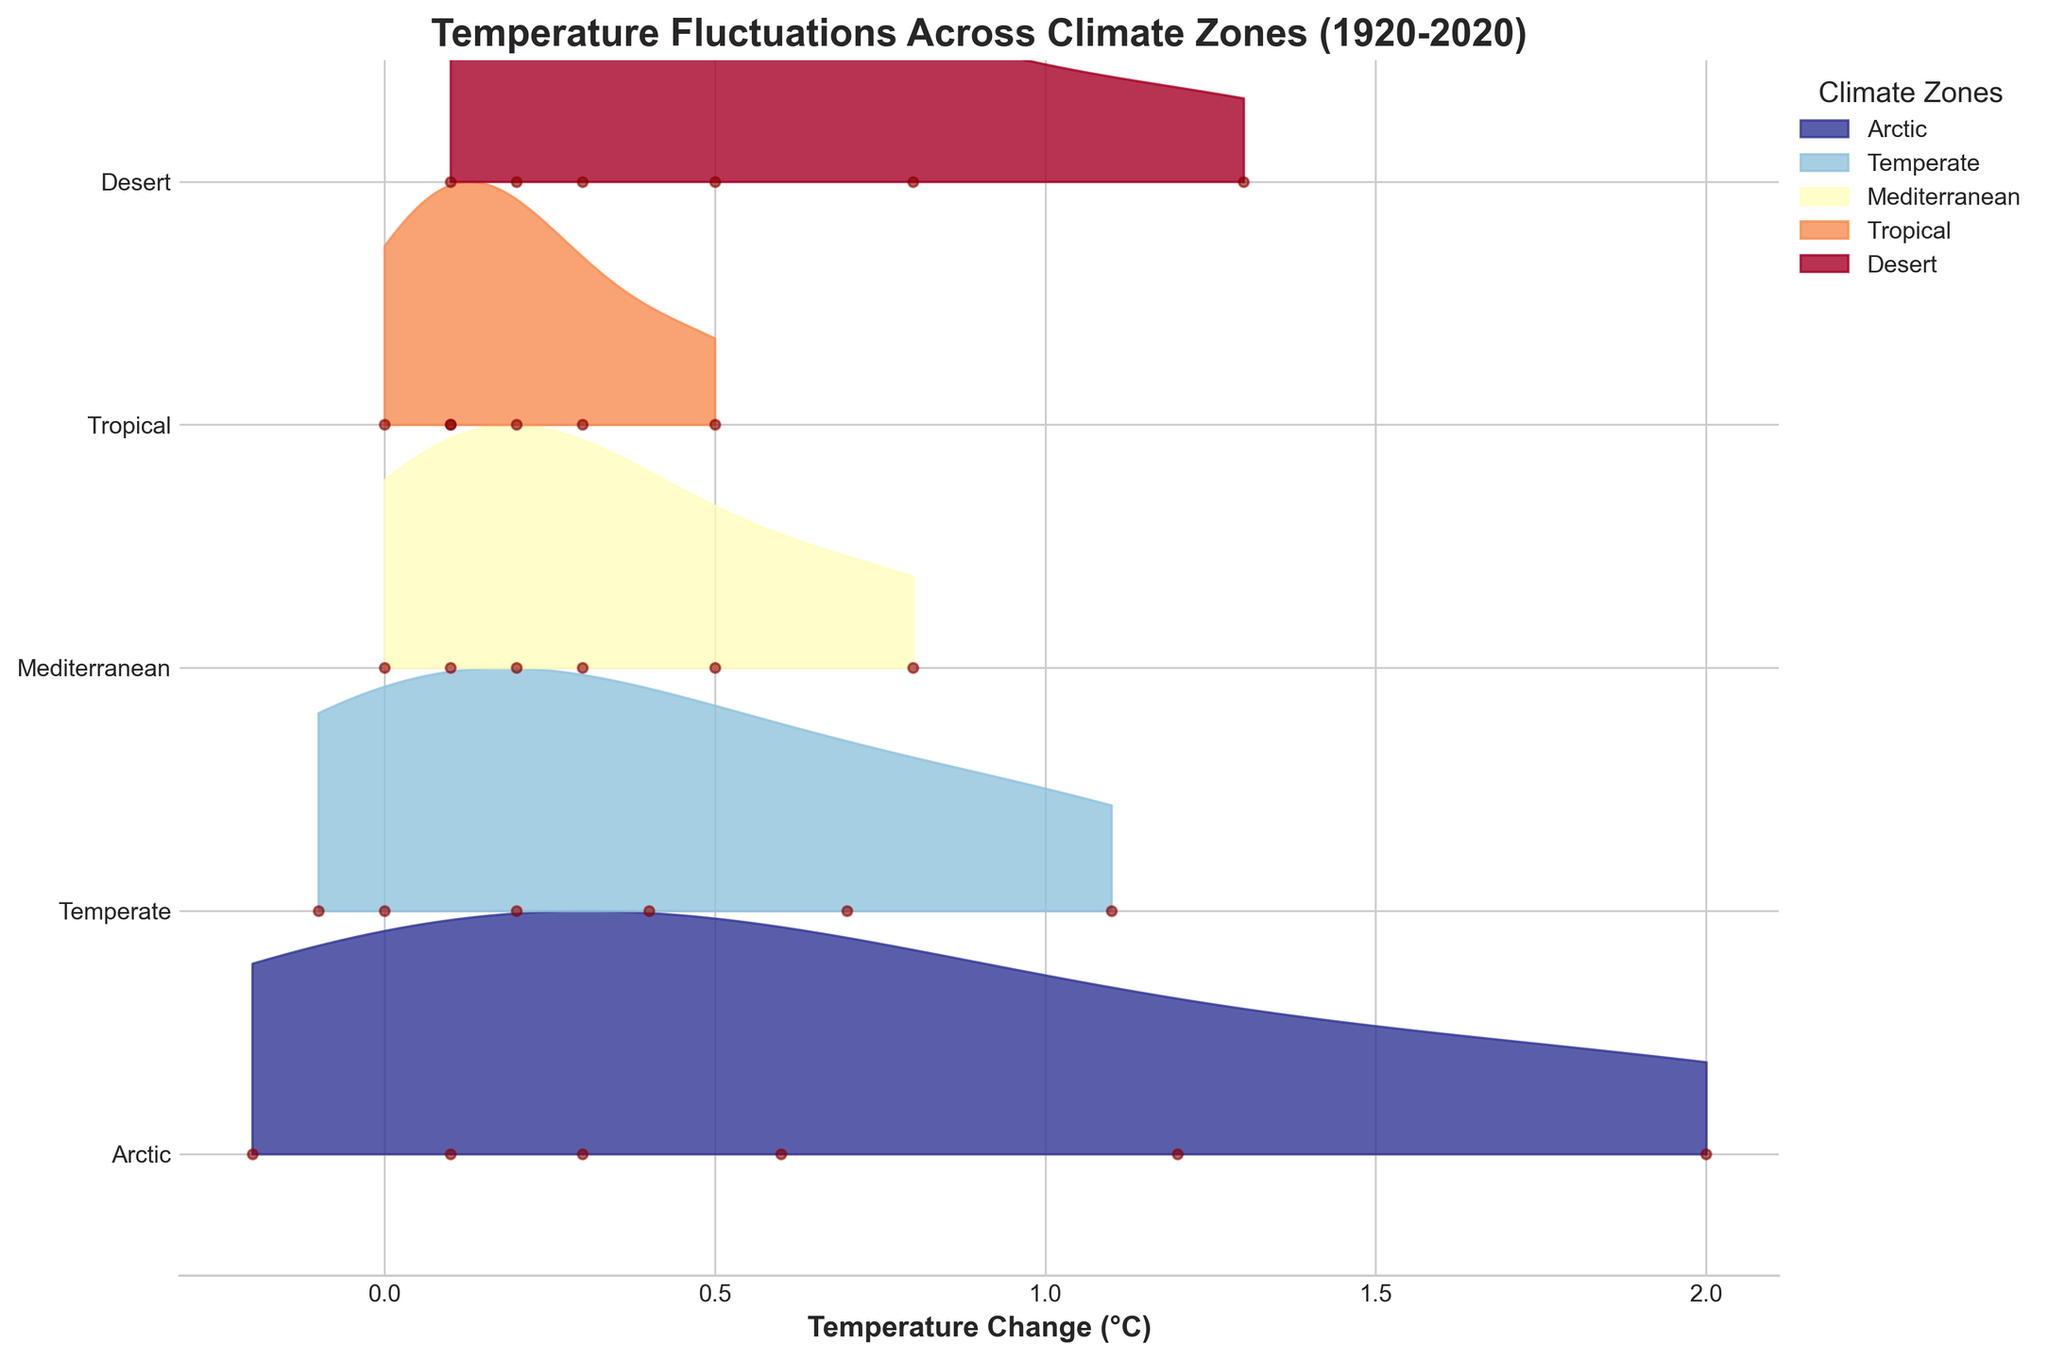What is the title of the figure? The title is the text located at the top of the figure. It gives an overview of what the plot represents. In this case, it is "Temperature Fluctuations Across Climate Zones (1920-2020)".
Answer: Temperature Fluctuations Across Climate Zones (1920-2020) Which climate zone has the highest temperature change in 2020? Identify the temperature changes for each climate zone in 2020. The Arctic has a temperature change of 2.0°C, which is the highest among all listed zones.
Answer: Arctic How many climate zones are represented in the plot? Each unique climate zone is represented by a line in the ridgeline plot. By counting the labels on the y-axis, we find there are five climate zones.
Answer: 5 Describe the trend in temperature change for the Arctic from 1920 to 2020. Observe the data points for the Arctic climate zone over the years. The temperature change increases monotonically from -0.2°C in 1920 to 2.0°C in 2020.
Answer: Increasing Which climate zone had the smallest temperature change in 1980? Look at the 1980 data points for all climate zones and compare their values. The Tropical climate zone has the smallest temperature change of 0.2°C in that year.
Answer: Tropical How do the temperature changes in the Temperate and Mediterranean climate zones compare in 2000? Compare the temperature changes for both zones in the year 2000. The Temperate zone has a temperature change of 0.7°C, while the Mediterranean zone has a change of 0.5°C. The Temperate zone’s change is higher.
Answer: Temperate zone is higher Between which two years did the Arctic climate zone experience the largest increase in temperature change? Calculate the differences in temperature change between consecutive years for the Arctic zone. The largest increase is from 2000 to 2020, where the change is from 1.2°C to 2.0°C, a difference of 0.8°C.
Answer: 2000 to 2020 What is a unique feature of the ridgeline plot used to display this data? A unique feature of a ridgeline plot is the overlapping density curves that show the distribution of values across categories. In this case, it helps to visualize temperature changes across multiple climate zones simultaneously.
Answer: Overlapping density curves How does the temperature change trend in the Desert climate zone compare to that in the Arctic climate zone from 1920 to 2020? Both the Arctic and Desert zones show an increasing trend. However, the Arctic’s increase is steeper, starting from -0.2°C to 2.0°C, whereas the Desert starts at 0.1°C to 1.3°C. The Arctic’s overall increase is larger.
Answer: Arctic has a steeper increase Which climate zone shows the least variation in temperature changes over the years? By observing the spread and overlap of the curves, the Tropical zone has the least variation, as the temperatures are clustered closely together around lower values compared to other zones.
Answer: Tropical 